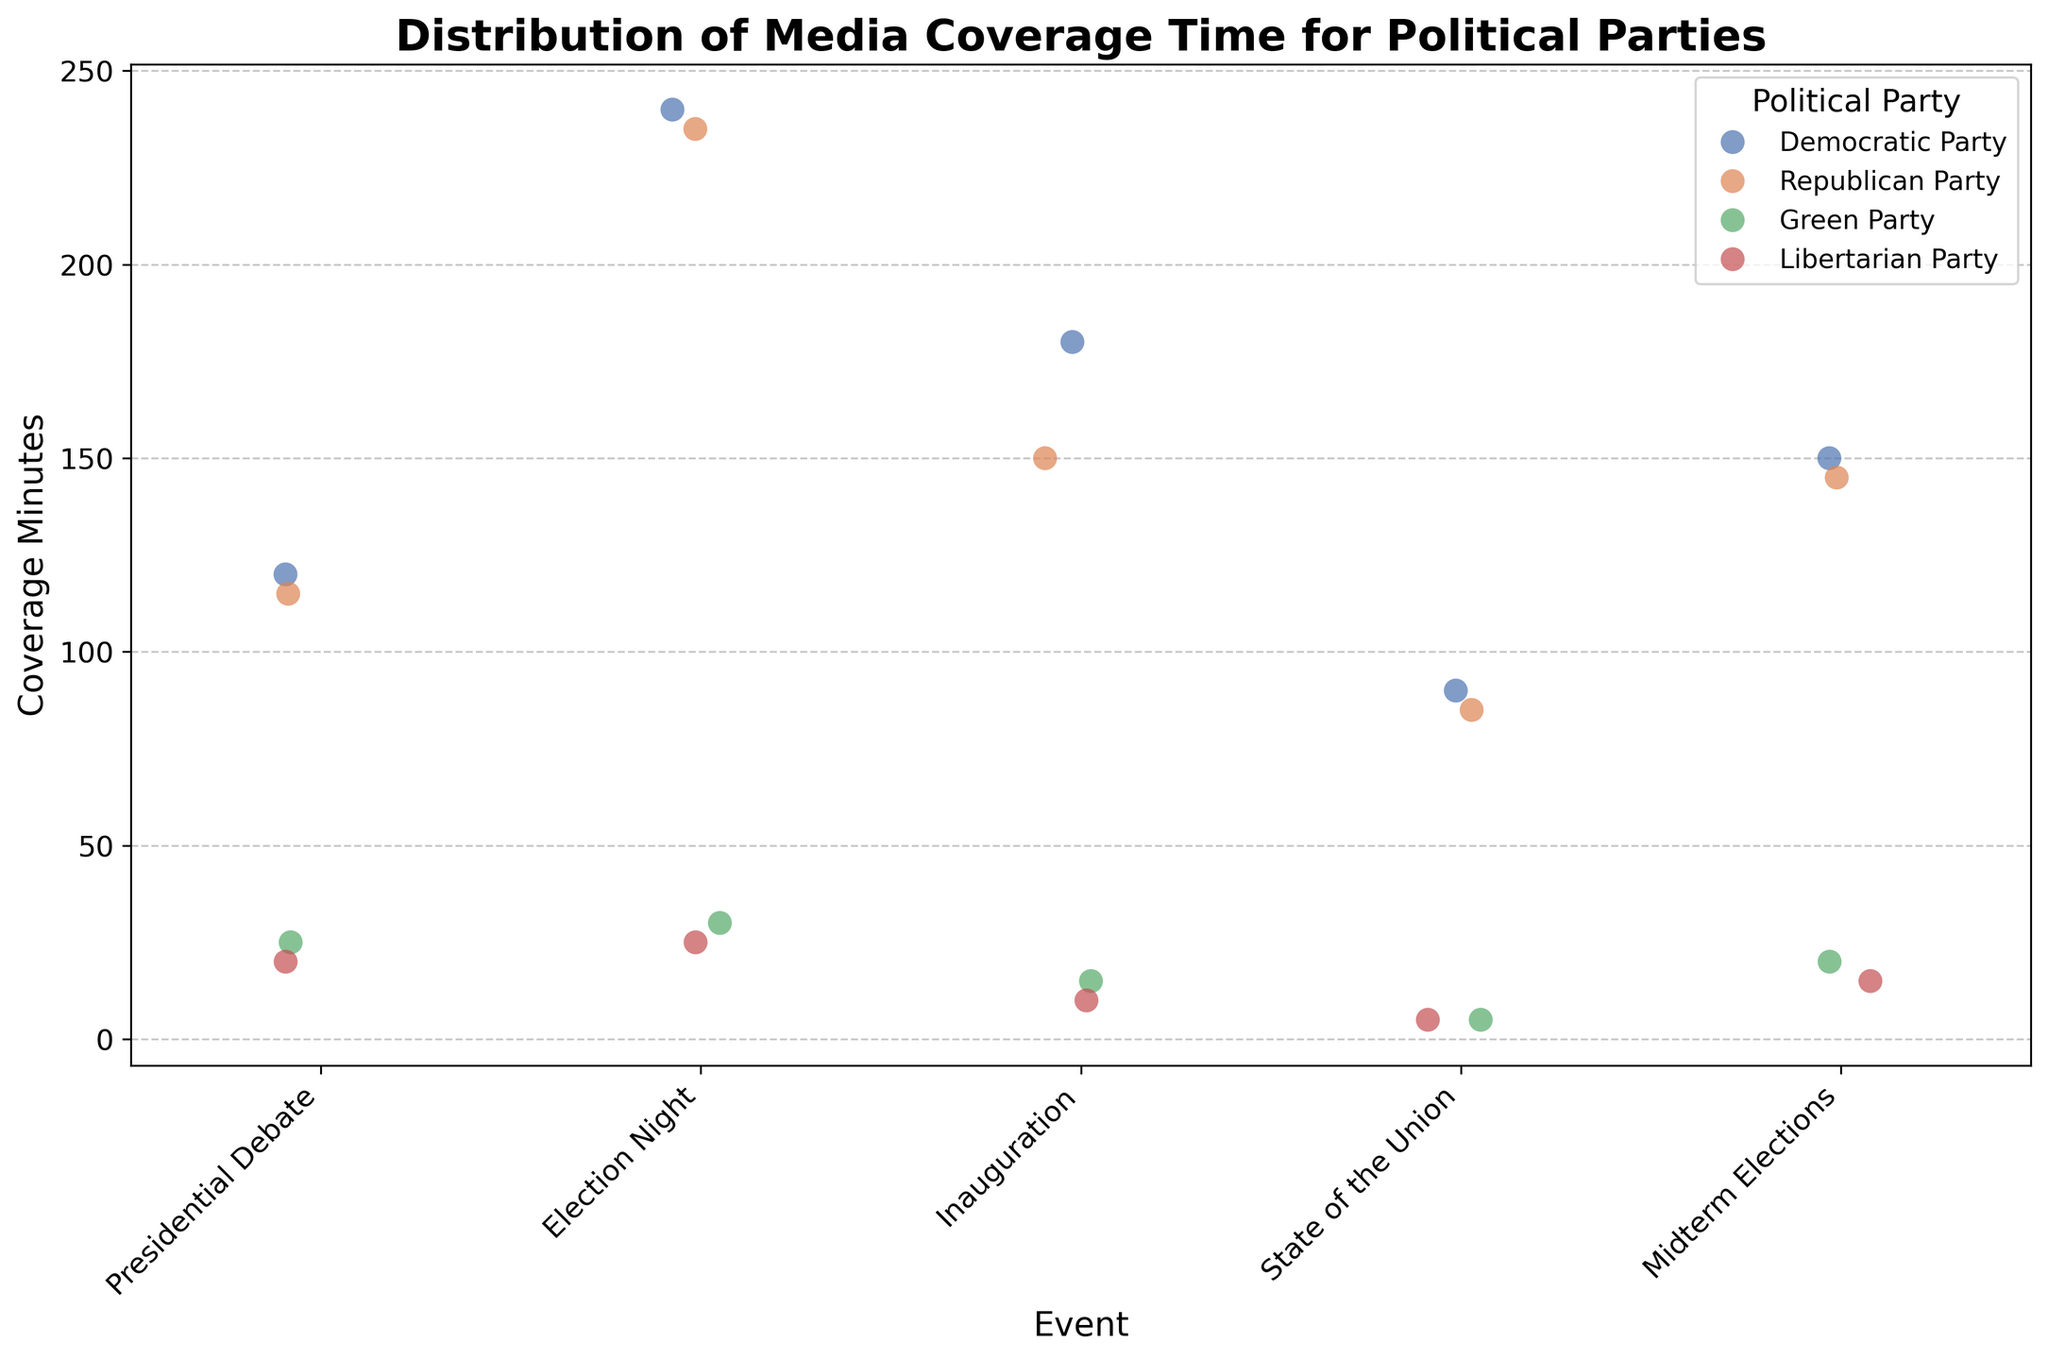What is the title of the plot? The title is located at the top of the plot. It specifies what the plot is about: "Distribution of Media Coverage Time for Political Parties".
Answer: Distribution of Media Coverage Time for Political Parties Which event has the highest media coverage time for the Republican Party? Check the y-axis values for media coverage time colored by the Republican Party for each event. The highest coverage is during Election Night (235 minutes).
Answer: Election Night How much more coverage did the Democratic Party receive compared to the Libertarian Party during the State of the Union? Look at the y-axis values for the Democratic and Libertarian Parties during the State of the Union. The Democratic Party had 90 minutes and the Libertarian Party had 5 minutes. The difference is 90 - 5 = 85 minutes.
Answer: 85 minutes Which event had the lowest media coverage for the Green Party? Identify the event with the smallest y-axis value for the Green Party. It is the State of the Union with 5 minutes.
Answer: State of the Union Is there any event where all four parties received different amounts of media coverage? Analyze each event to check if the y-axis values for coverage minutes are different for all four parties. The Presidential Debate fits this criterion.
Answer: Presidential Debate How many events did the Libertarian Party receive less than 20 minutes of coverage? Count the events where the y-axis values for the Libertarian Party are below 20 minutes: Inauguration (10), State of the Union (5), and Midterm Elections (15). This counts as 3 events.
Answer: 3 events What is the median media coverage time for the Democratic Party across all events? List the Democratic Party coverage times: 120, 240, 180, 90, and 150. Arrange them in ascending order: 90, 120, 150, 180, and 240. The median is the middle value, which is 150 minutes.
Answer: 150 minutes Which party received more media coverage during Election Night compared to the Midterm Elections? Compare the y-axis values for each party during Election Night and Midterm Elections. Both Democratic and Republican Parties have slightly higher coverage during Election Night (240, 235) than Midterm Elections (150, 145).
Answer: Both Democratic and Republican Parties What is the total media coverage time for the Green Party across all events? Add the y-axis values for the Green Party for each event: 25 + 30 + 15 + 5 + 20. This sums up to 95 minutes.
Answer: 95 minutes What can you infer about the trend in media coverage for minor parties (Green and Libertarian) across different events? Generally, the Green and Libertarian Parties receive significantly lower media coverage compared to Democratic and Republican Parties across all events. This is apparent from the distinctly lower y-axis values for these minor parties.
Answer: They receive significantly lower media coverage 